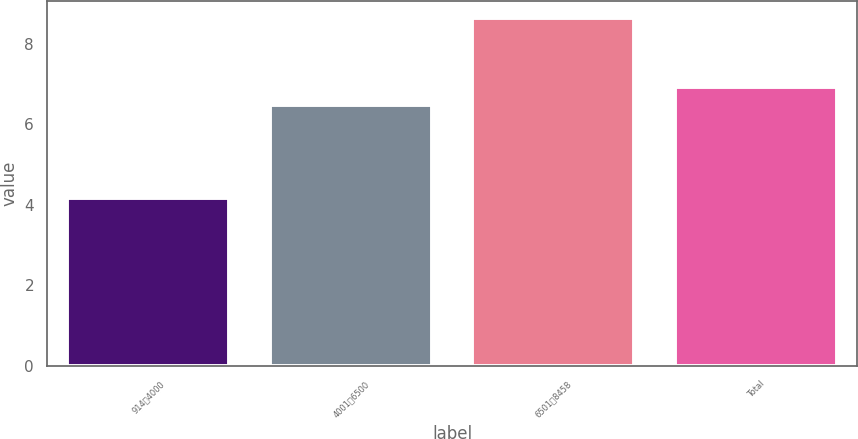<chart> <loc_0><loc_0><loc_500><loc_500><bar_chart><fcel>9144000<fcel>40016500<fcel>65018458<fcel>Total<nl><fcel>4.16<fcel>6.47<fcel>8.63<fcel>6.92<nl></chart> 